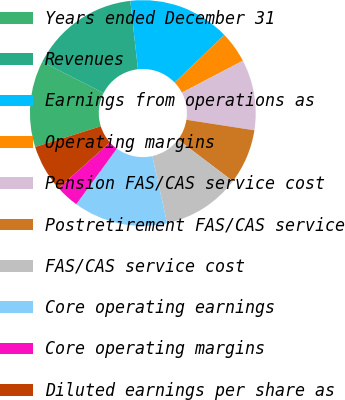Convert chart. <chart><loc_0><loc_0><loc_500><loc_500><pie_chart><fcel>Years ended December 31<fcel>Revenues<fcel>Earnings from operations as<fcel>Operating margins<fcel>Pension FAS/CAS service cost<fcel>Postretirement FAS/CAS service<fcel>FAS/CAS service cost<fcel>Core operating earnings<fcel>Core operating margins<fcel>Diluted earnings per share as<nl><fcel>12.36%<fcel>15.73%<fcel>14.61%<fcel>4.49%<fcel>10.11%<fcel>7.87%<fcel>11.24%<fcel>13.48%<fcel>3.37%<fcel>6.74%<nl></chart> 